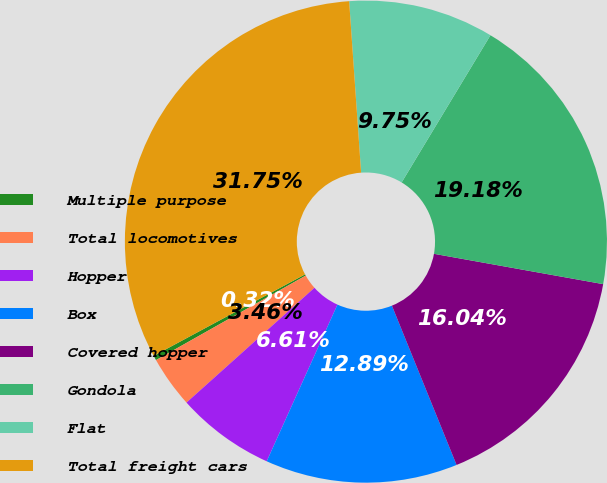Convert chart. <chart><loc_0><loc_0><loc_500><loc_500><pie_chart><fcel>Multiple purpose<fcel>Total locomotives<fcel>Hopper<fcel>Box<fcel>Covered hopper<fcel>Gondola<fcel>Flat<fcel>Total freight cars<nl><fcel>0.32%<fcel>3.46%<fcel>6.61%<fcel>12.89%<fcel>16.04%<fcel>19.18%<fcel>9.75%<fcel>31.75%<nl></chart> 